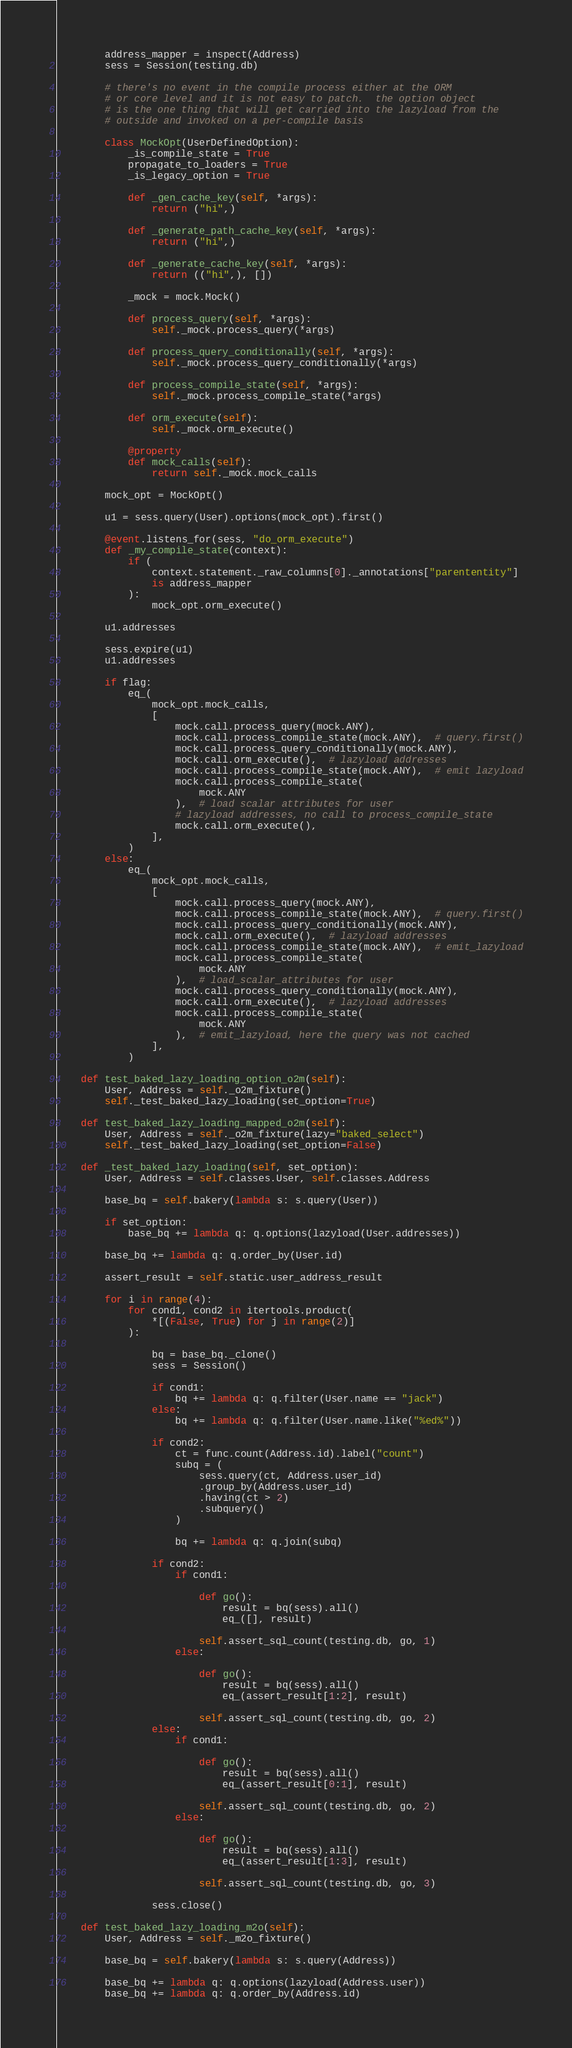<code> <loc_0><loc_0><loc_500><loc_500><_Python_>        address_mapper = inspect(Address)
        sess = Session(testing.db)

        # there's no event in the compile process either at the ORM
        # or core level and it is not easy to patch.  the option object
        # is the one thing that will get carried into the lazyload from the
        # outside and invoked on a per-compile basis

        class MockOpt(UserDefinedOption):
            _is_compile_state = True
            propagate_to_loaders = True
            _is_legacy_option = True

            def _gen_cache_key(self, *args):
                return ("hi",)

            def _generate_path_cache_key(self, *args):
                return ("hi",)

            def _generate_cache_key(self, *args):
                return (("hi",), [])

            _mock = mock.Mock()

            def process_query(self, *args):
                self._mock.process_query(*args)

            def process_query_conditionally(self, *args):
                self._mock.process_query_conditionally(*args)

            def process_compile_state(self, *args):
                self._mock.process_compile_state(*args)

            def orm_execute(self):
                self._mock.orm_execute()

            @property
            def mock_calls(self):
                return self._mock.mock_calls

        mock_opt = MockOpt()

        u1 = sess.query(User).options(mock_opt).first()

        @event.listens_for(sess, "do_orm_execute")
        def _my_compile_state(context):
            if (
                context.statement._raw_columns[0]._annotations["parententity"]
                is address_mapper
            ):
                mock_opt.orm_execute()

        u1.addresses

        sess.expire(u1)
        u1.addresses

        if flag:
            eq_(
                mock_opt.mock_calls,
                [
                    mock.call.process_query(mock.ANY),
                    mock.call.process_compile_state(mock.ANY),  # query.first()
                    mock.call.process_query_conditionally(mock.ANY),
                    mock.call.orm_execute(),  # lazyload addresses
                    mock.call.process_compile_state(mock.ANY),  # emit lazyload
                    mock.call.process_compile_state(
                        mock.ANY
                    ),  # load scalar attributes for user
                    # lazyload addresses, no call to process_compile_state
                    mock.call.orm_execute(),
                ],
            )
        else:
            eq_(
                mock_opt.mock_calls,
                [
                    mock.call.process_query(mock.ANY),
                    mock.call.process_compile_state(mock.ANY),  # query.first()
                    mock.call.process_query_conditionally(mock.ANY),
                    mock.call.orm_execute(),  # lazyload addresses
                    mock.call.process_compile_state(mock.ANY),  # emit_lazyload
                    mock.call.process_compile_state(
                        mock.ANY
                    ),  # load_scalar_attributes for user
                    mock.call.process_query_conditionally(mock.ANY),
                    mock.call.orm_execute(),  # lazyload addresses
                    mock.call.process_compile_state(
                        mock.ANY
                    ),  # emit_lazyload, here the query was not cached
                ],
            )

    def test_baked_lazy_loading_option_o2m(self):
        User, Address = self._o2m_fixture()
        self._test_baked_lazy_loading(set_option=True)

    def test_baked_lazy_loading_mapped_o2m(self):
        User, Address = self._o2m_fixture(lazy="baked_select")
        self._test_baked_lazy_loading(set_option=False)

    def _test_baked_lazy_loading(self, set_option):
        User, Address = self.classes.User, self.classes.Address

        base_bq = self.bakery(lambda s: s.query(User))

        if set_option:
            base_bq += lambda q: q.options(lazyload(User.addresses))

        base_bq += lambda q: q.order_by(User.id)

        assert_result = self.static.user_address_result

        for i in range(4):
            for cond1, cond2 in itertools.product(
                *[(False, True) for j in range(2)]
            ):

                bq = base_bq._clone()
                sess = Session()

                if cond1:
                    bq += lambda q: q.filter(User.name == "jack")
                else:
                    bq += lambda q: q.filter(User.name.like("%ed%"))

                if cond2:
                    ct = func.count(Address.id).label("count")
                    subq = (
                        sess.query(ct, Address.user_id)
                        .group_by(Address.user_id)
                        .having(ct > 2)
                        .subquery()
                    )

                    bq += lambda q: q.join(subq)

                if cond2:
                    if cond1:

                        def go():
                            result = bq(sess).all()
                            eq_([], result)

                        self.assert_sql_count(testing.db, go, 1)
                    else:

                        def go():
                            result = bq(sess).all()
                            eq_(assert_result[1:2], result)

                        self.assert_sql_count(testing.db, go, 2)
                else:
                    if cond1:

                        def go():
                            result = bq(sess).all()
                            eq_(assert_result[0:1], result)

                        self.assert_sql_count(testing.db, go, 2)
                    else:

                        def go():
                            result = bq(sess).all()
                            eq_(assert_result[1:3], result)

                        self.assert_sql_count(testing.db, go, 3)

                sess.close()

    def test_baked_lazy_loading_m2o(self):
        User, Address = self._m2o_fixture()

        base_bq = self.bakery(lambda s: s.query(Address))

        base_bq += lambda q: q.options(lazyload(Address.user))
        base_bq += lambda q: q.order_by(Address.id)
</code> 